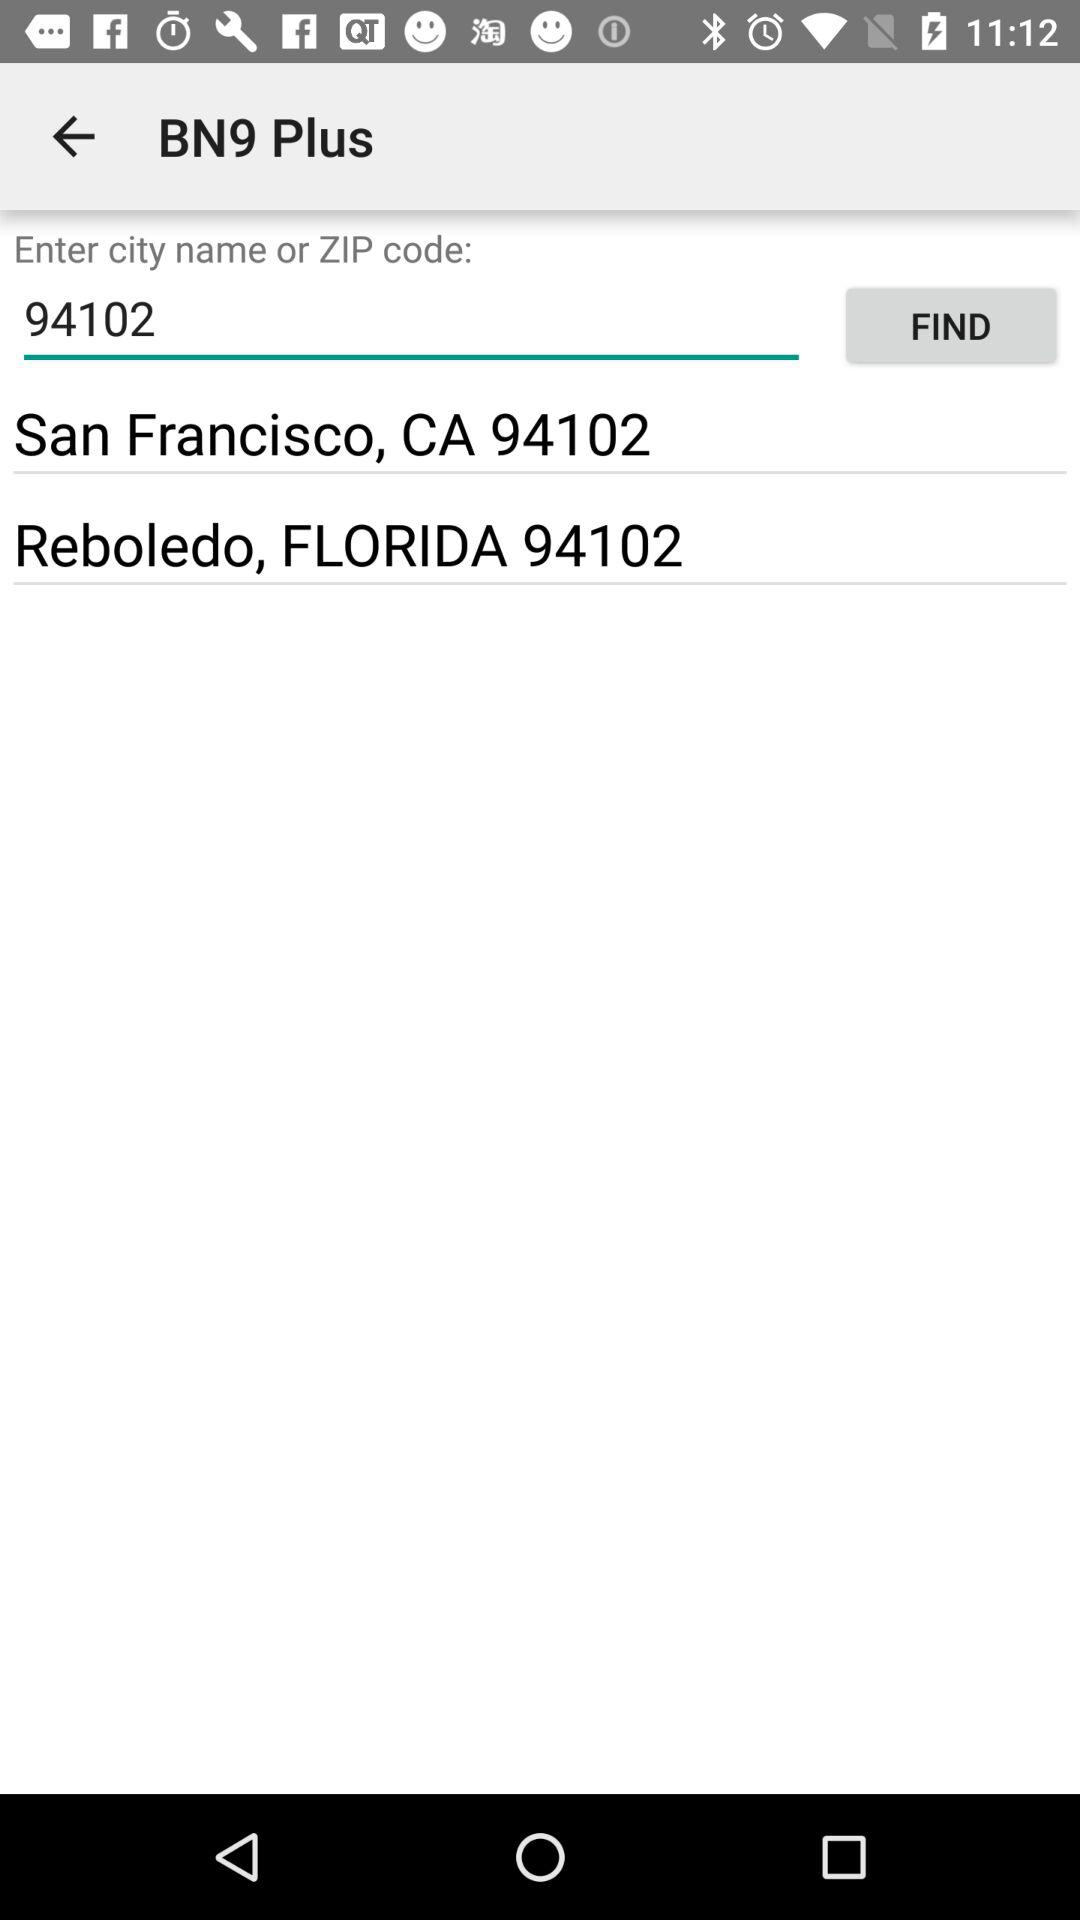What are the mentioned locations? The mentioned locations are "San Francisco, CA 94102" and "Reboledo, FLORIDA 94102". 